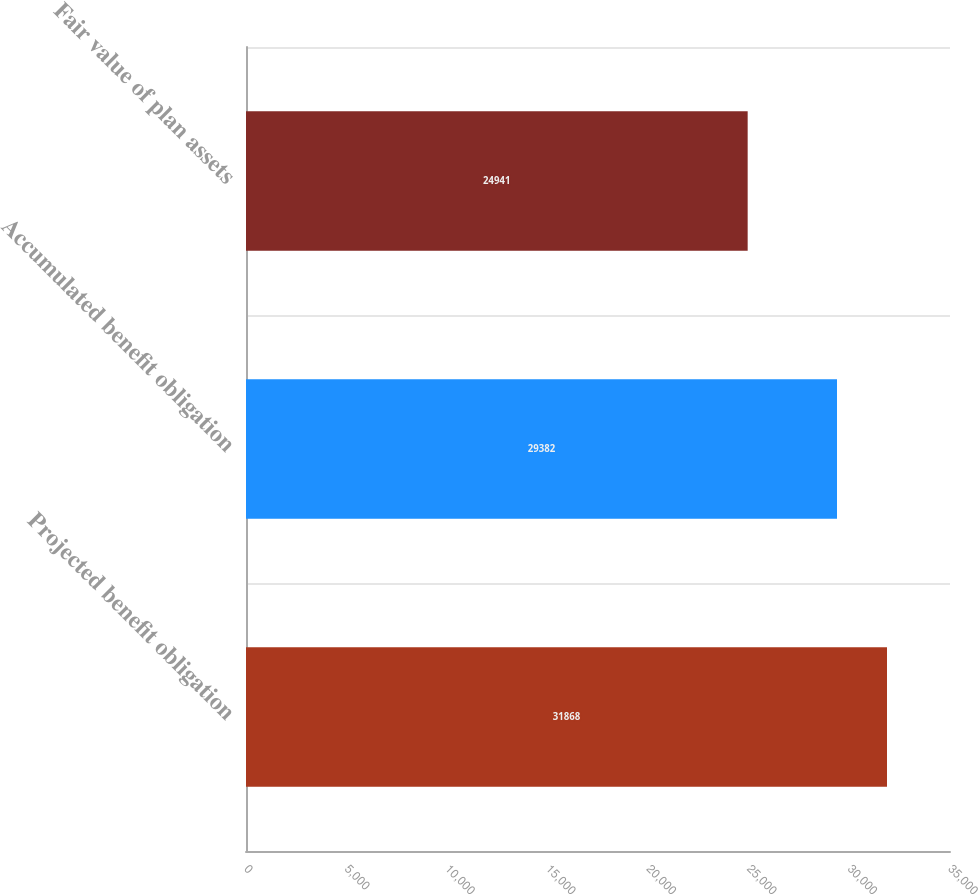Convert chart to OTSL. <chart><loc_0><loc_0><loc_500><loc_500><bar_chart><fcel>Projected benefit obligation<fcel>Accumulated benefit obligation<fcel>Fair value of plan assets<nl><fcel>31868<fcel>29382<fcel>24941<nl></chart> 